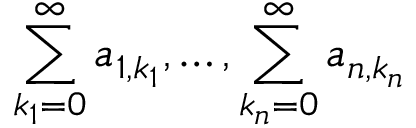<formula> <loc_0><loc_0><loc_500><loc_500>\sum _ { k _ { 1 } = 0 } ^ { \infty } a _ { 1 , k _ { 1 } } , \dots , \sum _ { k _ { n } = 0 } ^ { \infty } a _ { n , k _ { n } }</formula> 